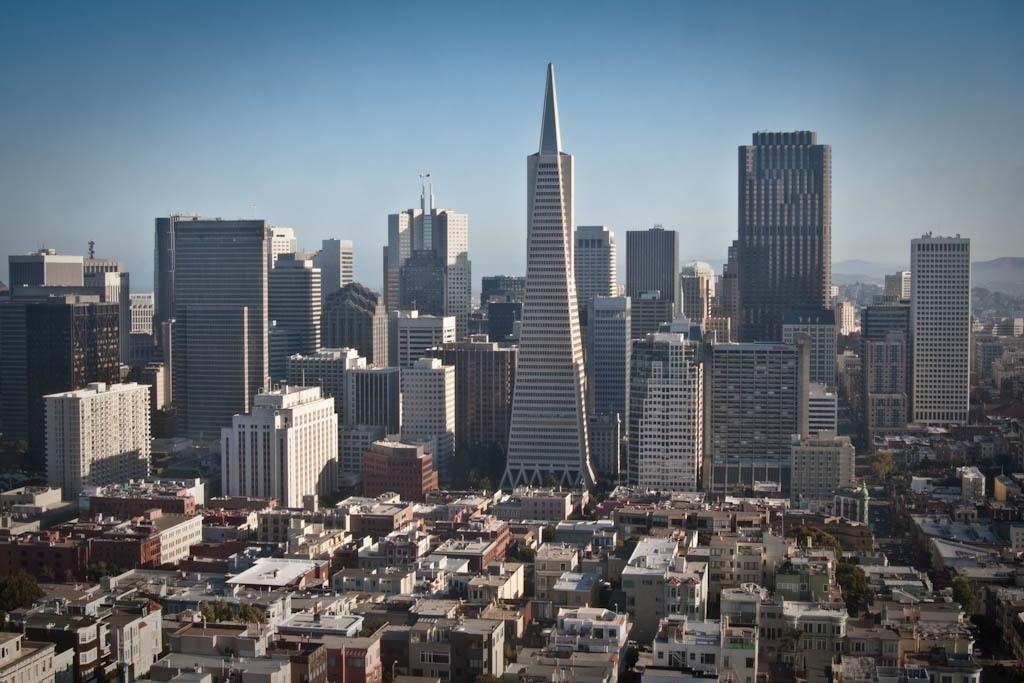What type of structures are located at the bottom of the image? There are buildings at the bottom of the image. What can be seen in the background of the image? There are tower buildings in the background. What is visible in the sky in the image? There are clouds in the sky. How many chickens can be seen on top of the tower buildings in the image? There are no chickens present in the image; it features buildings and clouds. What type of friction is visible between the clouds and the tower buildings in the image? There is no friction visible between the clouds and the tower buildings in the image; they are not in contact with each other. 